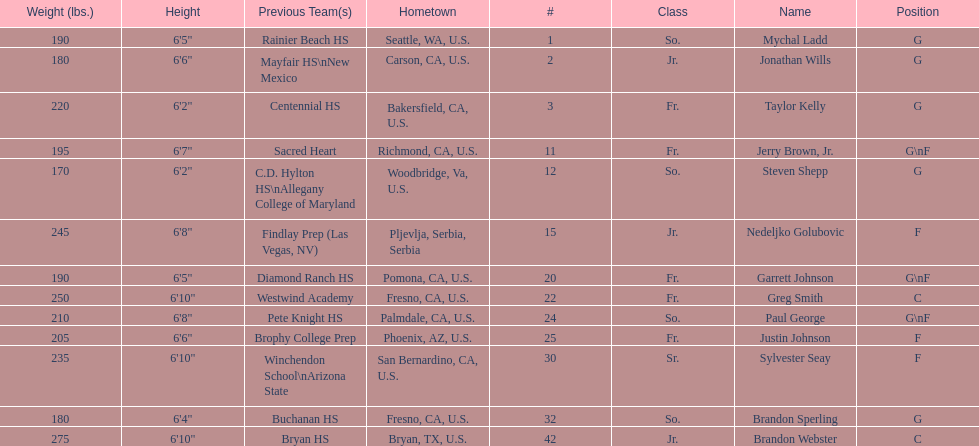Which player previously played for sacred heart? Jerry Brown, Jr. 